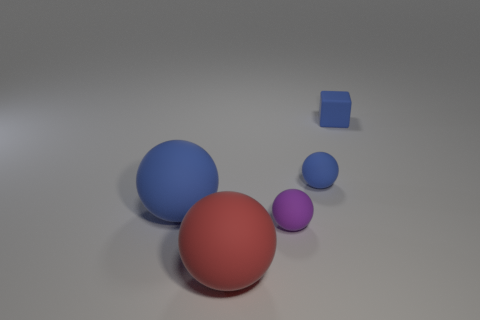How do the shadows in the image inform us about the light source? The shadows of the objects are cast toward the bottom-right of the image, suggesting that the light source is located toward the upper-left side but not directly above, as the shadows are not beneath the objects but displaced at an angle.  What kind of mood does the lighting and color scheme evoke? The soft, diffused lighting and the muted color palette create a serene and calm atmosphere. The colors, with their matte finish, contribute to a feeling of understated simplicity and can evoke contemplation or introspection. 